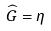<formula> <loc_0><loc_0><loc_500><loc_500>\widehat { G } = \eta</formula> 